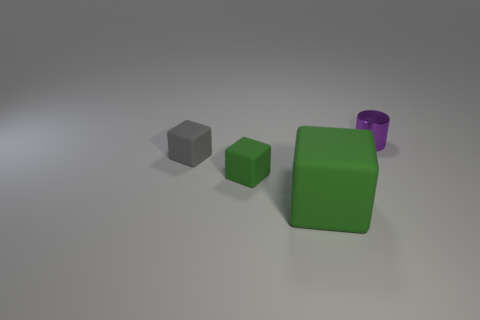There is a gray object that is made of the same material as the tiny green cube; what is its shape?
Make the answer very short. Cube. Are there more small things that are behind the tiny purple metal object than small gray rubber blocks on the right side of the gray thing?
Provide a short and direct response. No. What is the size of the green object in front of the green object that is behind the large green object that is in front of the small gray cube?
Your response must be concise. Large. Are there any tiny rubber blocks of the same color as the big rubber object?
Offer a very short reply. Yes. How many purple metal cylinders are there?
Make the answer very short. 1. There is a green cube behind the green matte object to the right of the green rubber object left of the large green rubber thing; what is its material?
Ensure brevity in your answer.  Rubber. Are there any small cubes that have the same material as the small purple thing?
Make the answer very short. No. Are the purple object and the small green thing made of the same material?
Make the answer very short. No. What number of blocks are either gray objects or large yellow things?
Your answer should be compact. 1. What color is the other small block that is made of the same material as the small gray block?
Make the answer very short. Green. 